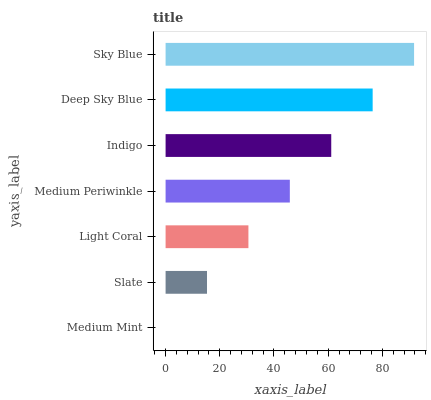Is Medium Mint the minimum?
Answer yes or no. Yes. Is Sky Blue the maximum?
Answer yes or no. Yes. Is Slate the minimum?
Answer yes or no. No. Is Slate the maximum?
Answer yes or no. No. Is Slate greater than Medium Mint?
Answer yes or no. Yes. Is Medium Mint less than Slate?
Answer yes or no. Yes. Is Medium Mint greater than Slate?
Answer yes or no. No. Is Slate less than Medium Mint?
Answer yes or no. No. Is Medium Periwinkle the high median?
Answer yes or no. Yes. Is Medium Periwinkle the low median?
Answer yes or no. Yes. Is Indigo the high median?
Answer yes or no. No. Is Light Coral the low median?
Answer yes or no. No. 